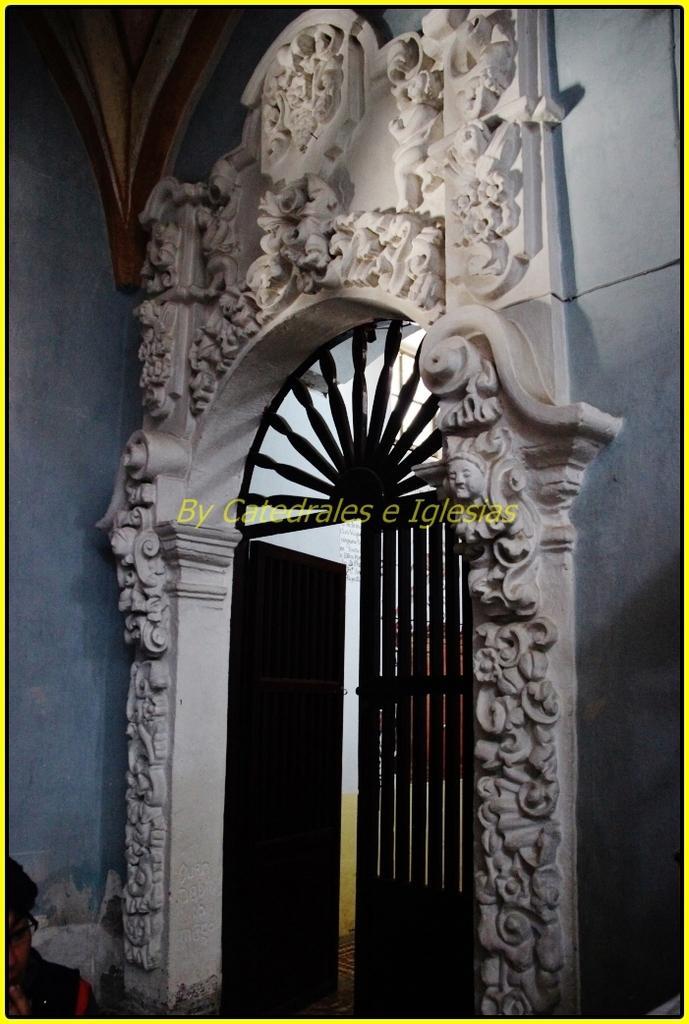How would you summarize this image in a sentence or two? In the image we can see fence gate and we can see a person wearing clothes and spectacles. Here we can see a wall and a watermark in between the image. 